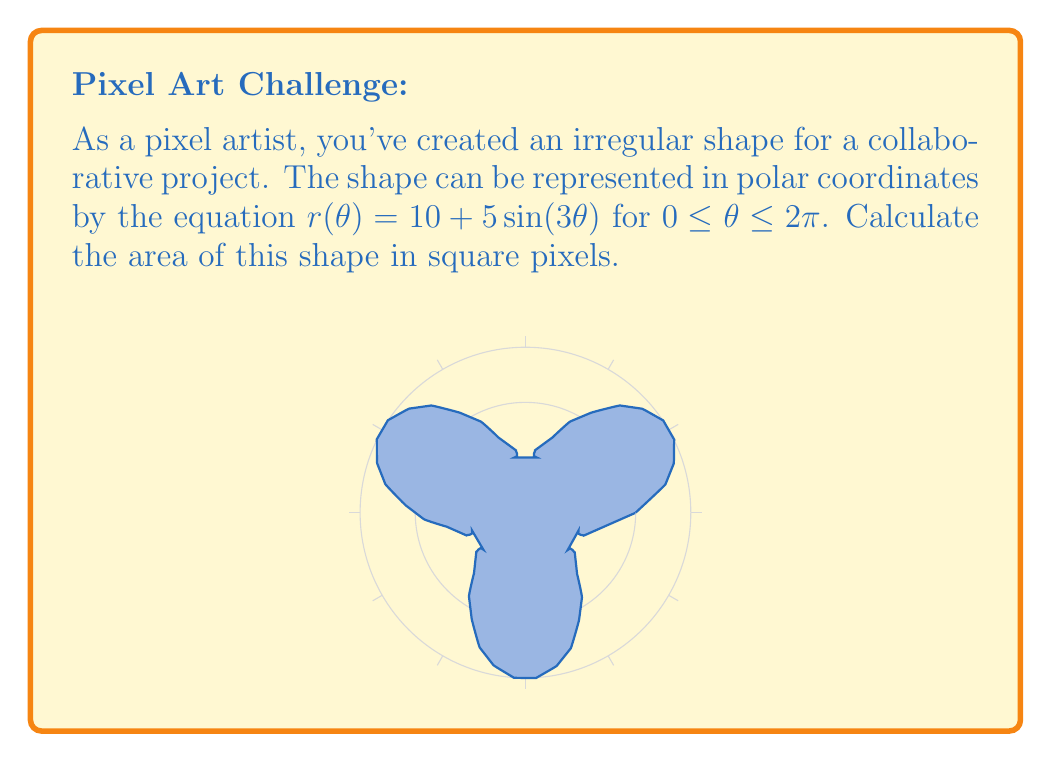Can you answer this question? To find the area of this irregular shape in polar coordinates, we'll use the formula:

$$A = \frac{1}{2} \int_{0}^{2\pi} [r(\theta)]^2 d\theta$$

Let's break this down step-by-step:

1) We're given $r(\theta) = 10 + 5\sin(3\theta)$

2) Square this function:
   $[r(\theta)]^2 = (10 + 5\sin(3\theta))^2 = 100 + 100\sin(3\theta) + 25\sin^2(3\theta)$

3) Now, let's set up our integral:
   $$A = \frac{1}{2} \int_{0}^{2\pi} (100 + 100\sin(3\theta) + 25\sin^2(3\theta)) d\theta$$

4) Let's integrate each term separately:
   
   a) $\int_{0}^{2\pi} 100 d\theta = 100\theta \big|_{0}^{2\pi} = 200\pi$
   
   b) $\int_{0}^{2\pi} 100\sin(3\theta) d\theta = -\frac{100}{3}\cos(3\theta) \big|_{0}^{2\pi} = 0$
   
   c) For $\int_{0}^{2\pi} 25\sin^2(3\theta) d\theta$, we can use the identity $\sin^2(x) = \frac{1 - \cos(2x)}{2}$:
      
      $25 \int_{0}^{2\pi} \frac{1 - \cos(6\theta)}{2} d\theta = 25(\frac{\theta}{2} - \frac{\sin(6\theta)}{12}) \big|_{0}^{2\pi} = 25\pi$

5) Sum these results:
   $A = \frac{1}{2}(200\pi + 0 + 25\pi) = \frac{225\pi}{2} = 112.5\pi$

Therefore, the area of the shape is $112.5\pi$ square pixels.
Answer: $112.5\pi$ square pixels 